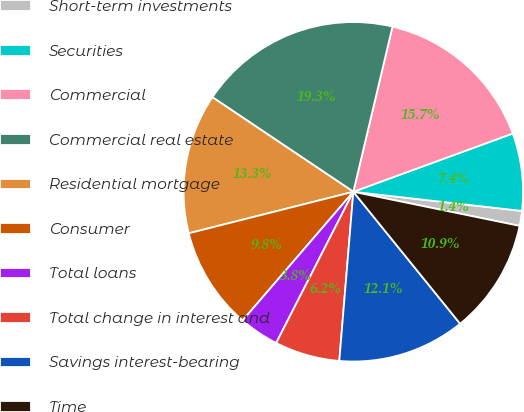<chart> <loc_0><loc_0><loc_500><loc_500><pie_chart><fcel>Short-term investments<fcel>Securities<fcel>Commercial<fcel>Commercial real estate<fcel>Residential mortgage<fcel>Consumer<fcel>Total loans<fcel>Total change in interest and<fcel>Savings interest-bearing<fcel>Time<nl><fcel>1.42%<fcel>7.38%<fcel>15.72%<fcel>19.3%<fcel>13.34%<fcel>9.76%<fcel>3.8%<fcel>6.19%<fcel>12.15%<fcel>10.95%<nl></chart> 